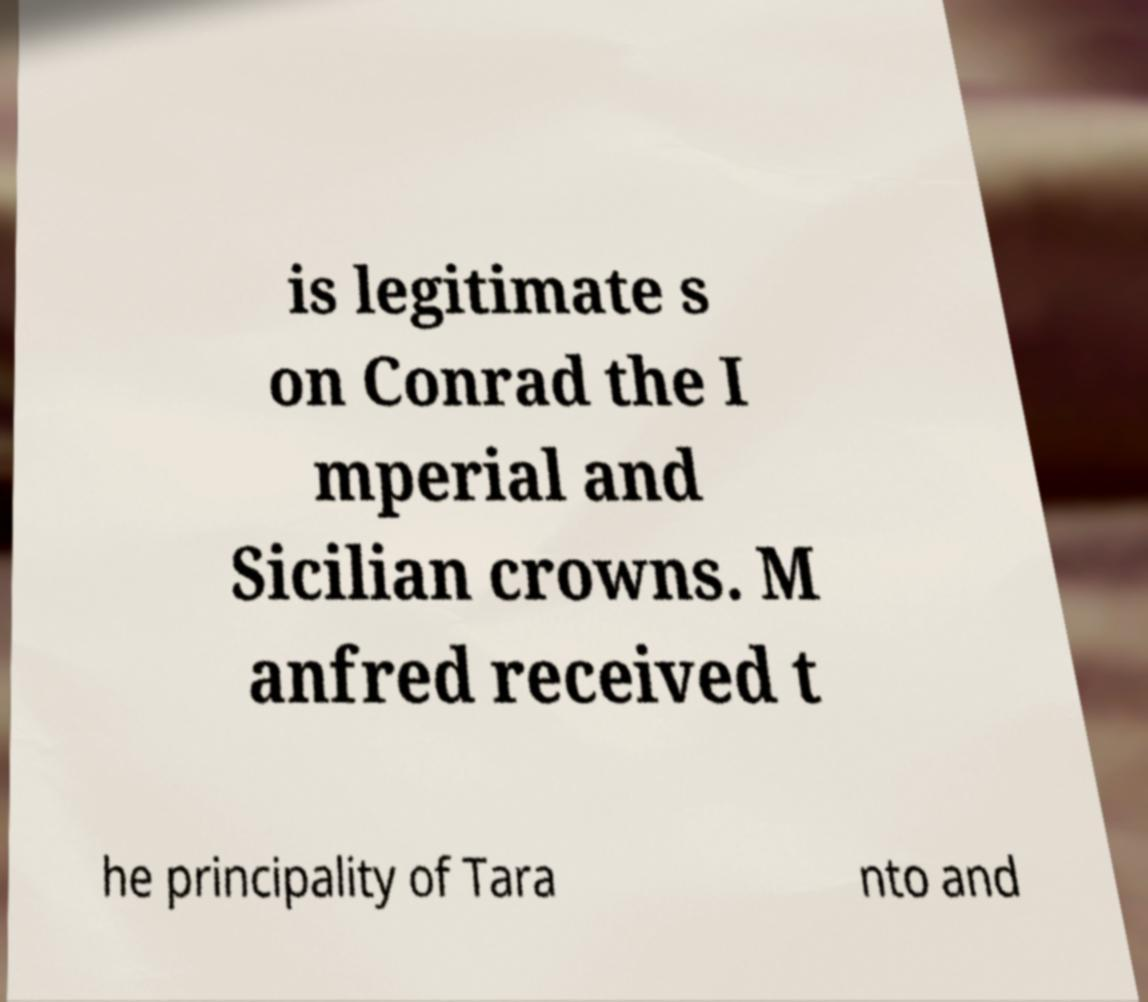For documentation purposes, I need the text within this image transcribed. Could you provide that? is legitimate s on Conrad the I mperial and Sicilian crowns. M anfred received t he principality of Tara nto and 